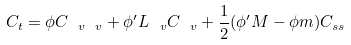<formula> <loc_0><loc_0><loc_500><loc_500>C _ { t } = \phi C _ { \ v \ v } + \phi ^ { \prime } L _ { \ v } C _ { \ v } + \frac { 1 } { 2 } ( \phi ^ { \prime } M - \phi m ) C _ { s s }</formula> 